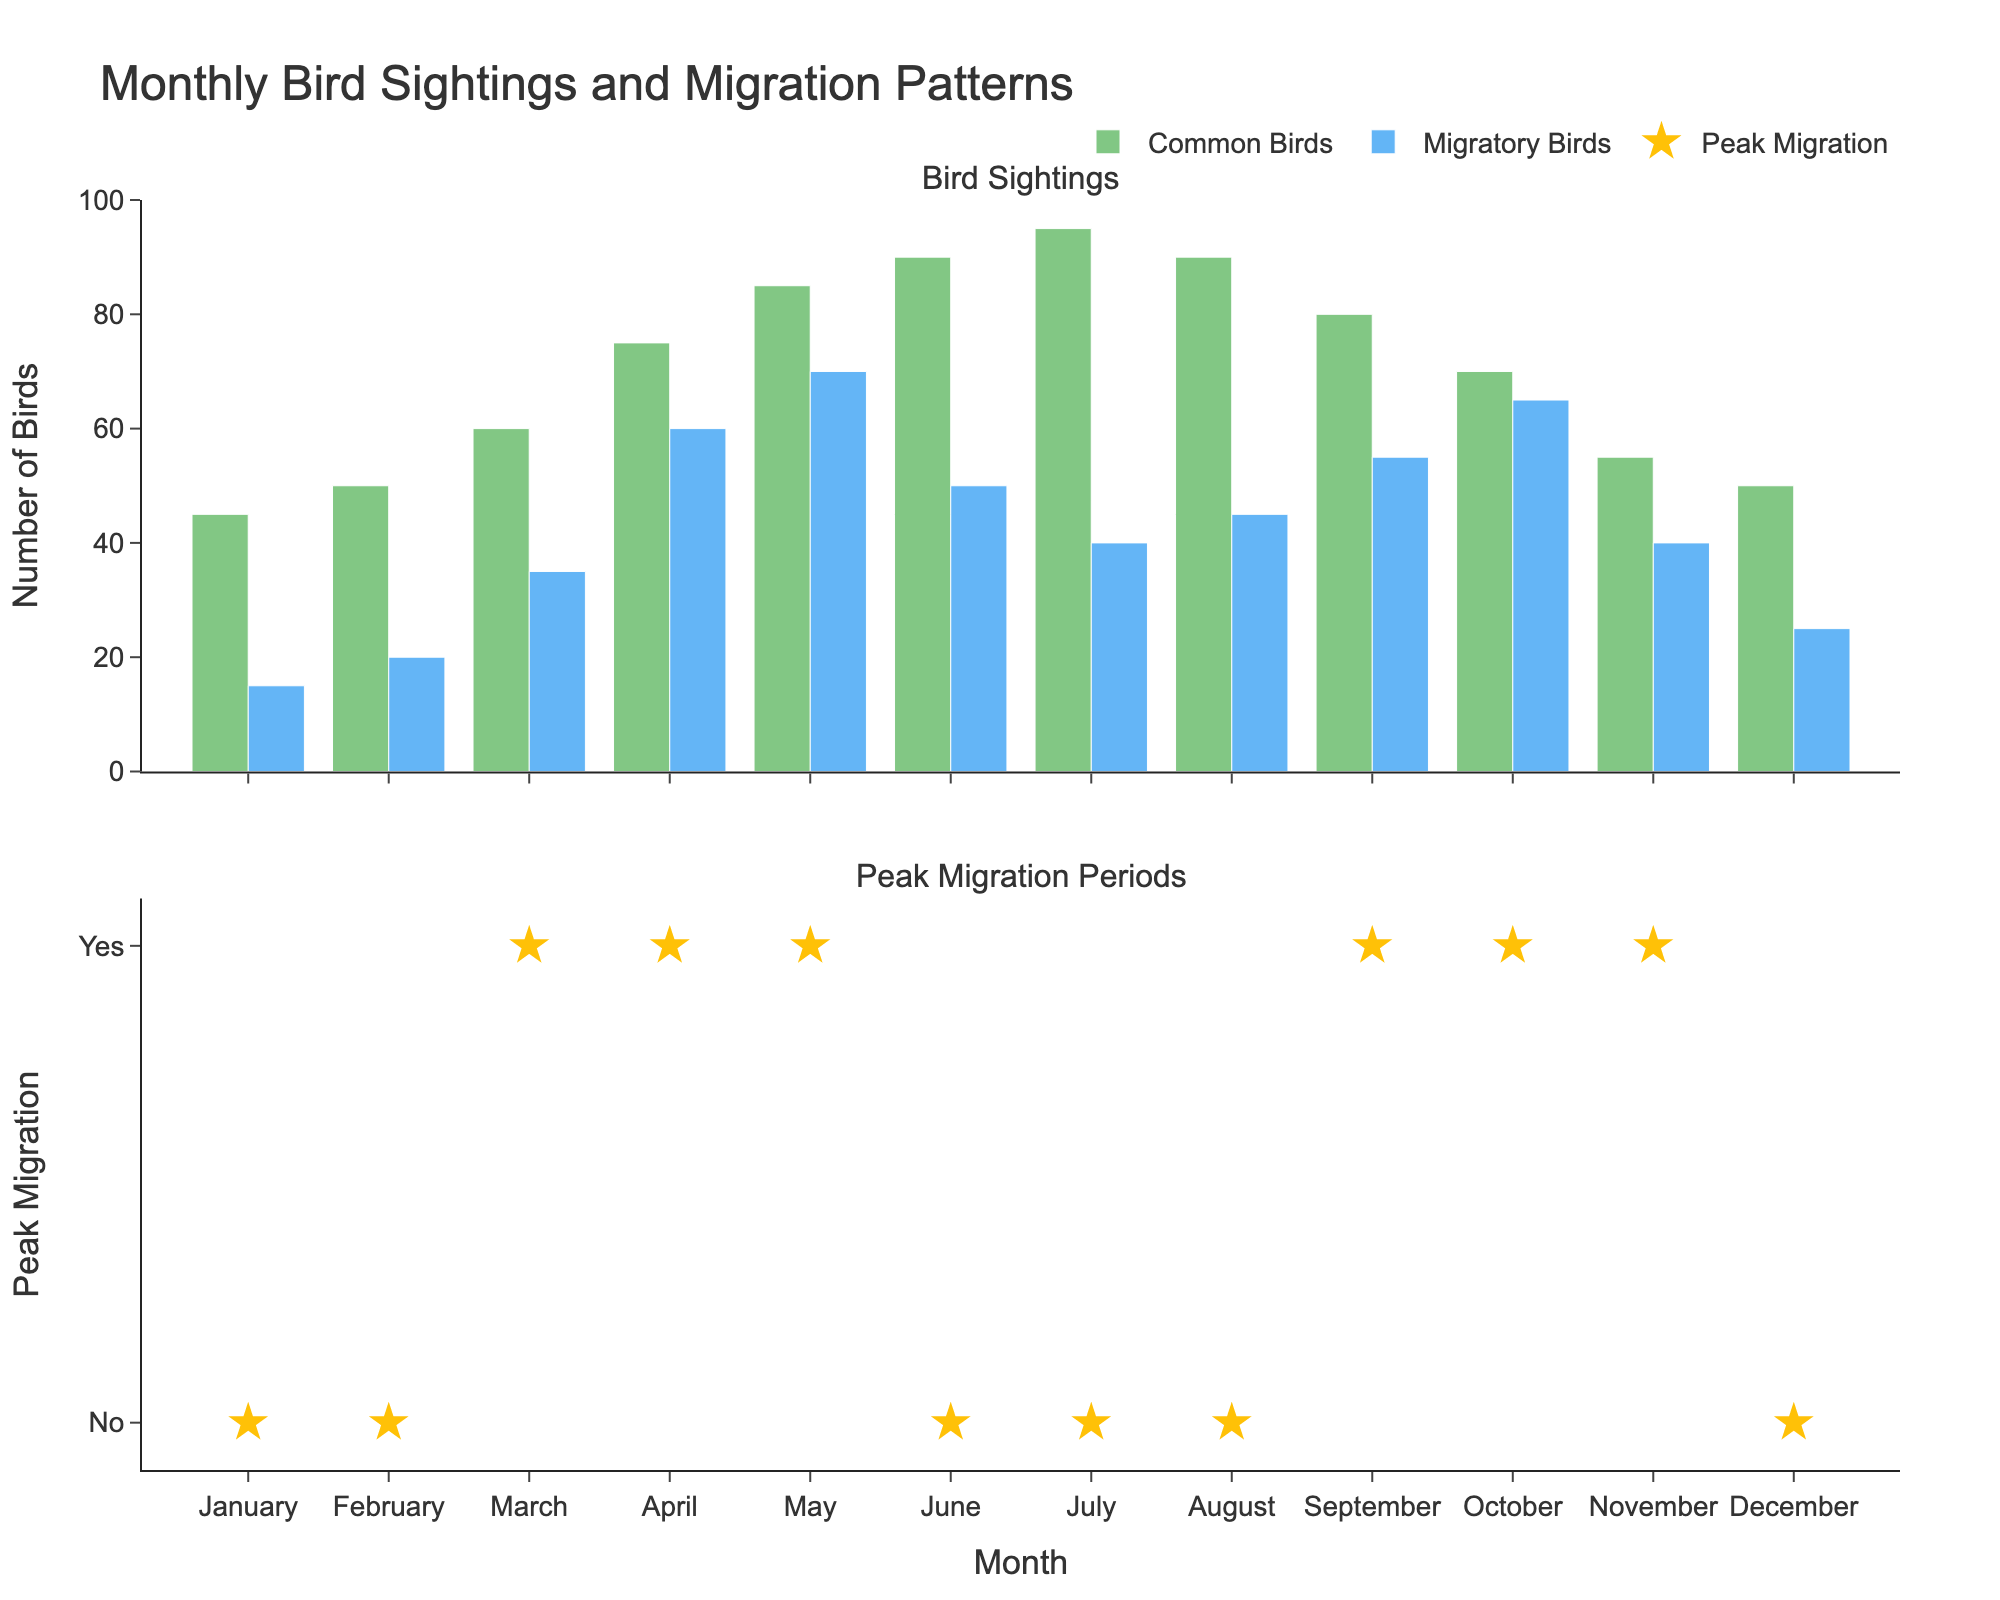What is the average speed in the 500m sprint event in 2015? The 2015 data point for the 500m Sprint event in the subplot shows an average speed of 44.2 km/h
Answer: 44.2 km/h How does the average speed in the 10000m event change from 2003 to 2019? By referring to the subplot for the 10000m event, the speed increased from 33.8 km/h in 2003 to 35.6 km/h in 2019
Answer: Increased from 33.8 km/h to 35.6 km/h Which event shows the highest average speed in 2019? Looking at all subplots and the final data points for 2019, the 500m Sprint event shows the highest average speed of 44.9 km/h
Answer: 500m Sprint What is the difference in speed between the 500m sprint and 1000m events in 2007? Referencing the 2007 data points in both subplots, the difference is calculated as 43.1 km/h - 38.9 km/h = 4.2 km/h
Answer: 4.2 km/h Which event shows the least increase in average speed from 2003 to 2019? By checking the starting and ending data points for each event, the 10000m event shows an increase from 33.8 km/h to 35.6 km/h, the smallest increase of 1.8 km/h compared to other events
Answer: 10000m What can be observed about the trend in the 5000m event from 2003 to 2019? The subplot for the 5000m event shows a consistent upward trend in average speeds from 35.1 km/h in 2003 to 37.1 km/h in 2019
Answer: Consistent upward trend Which event shows the greatest rate of increase in average speed over the years? By calculating the rate of increase for each event, the 500m Sprint shows the greatest increase from 42.5 km/h in 2003 to 44.9 km/h in 2019, with an increase of 2.4 km/h over 16 years
Answer: 500m Sprint How does the average speed for the 1000m event in 2011 compare to the 500m Sprint speed in 2003? The 2011 speed for 1000m is 39.5 km/h and the 2003 speed for 500m Sprint is 42.5 km/h. Comparatively, the 500m Sprint speed in 2003 is higher
Answer: 500m Sprint is higher What is the trend in the average speed for the 1000m event between 2015 and 2019? Observing the 1000m event subplot, there is an upward trend, with an increase from 40.1 km/h in 2015 to 40.8 km/h in 2019
Answer: Upward trend Of the four events, which has the most consistent speed increases across all years? By examining the subplots, the 500m Sprint event shows the most consistent and steady increase in average speeds from 42.5 km/h in 2003 to 44.9 km/h in 2019
Answer: 500m Sprint 